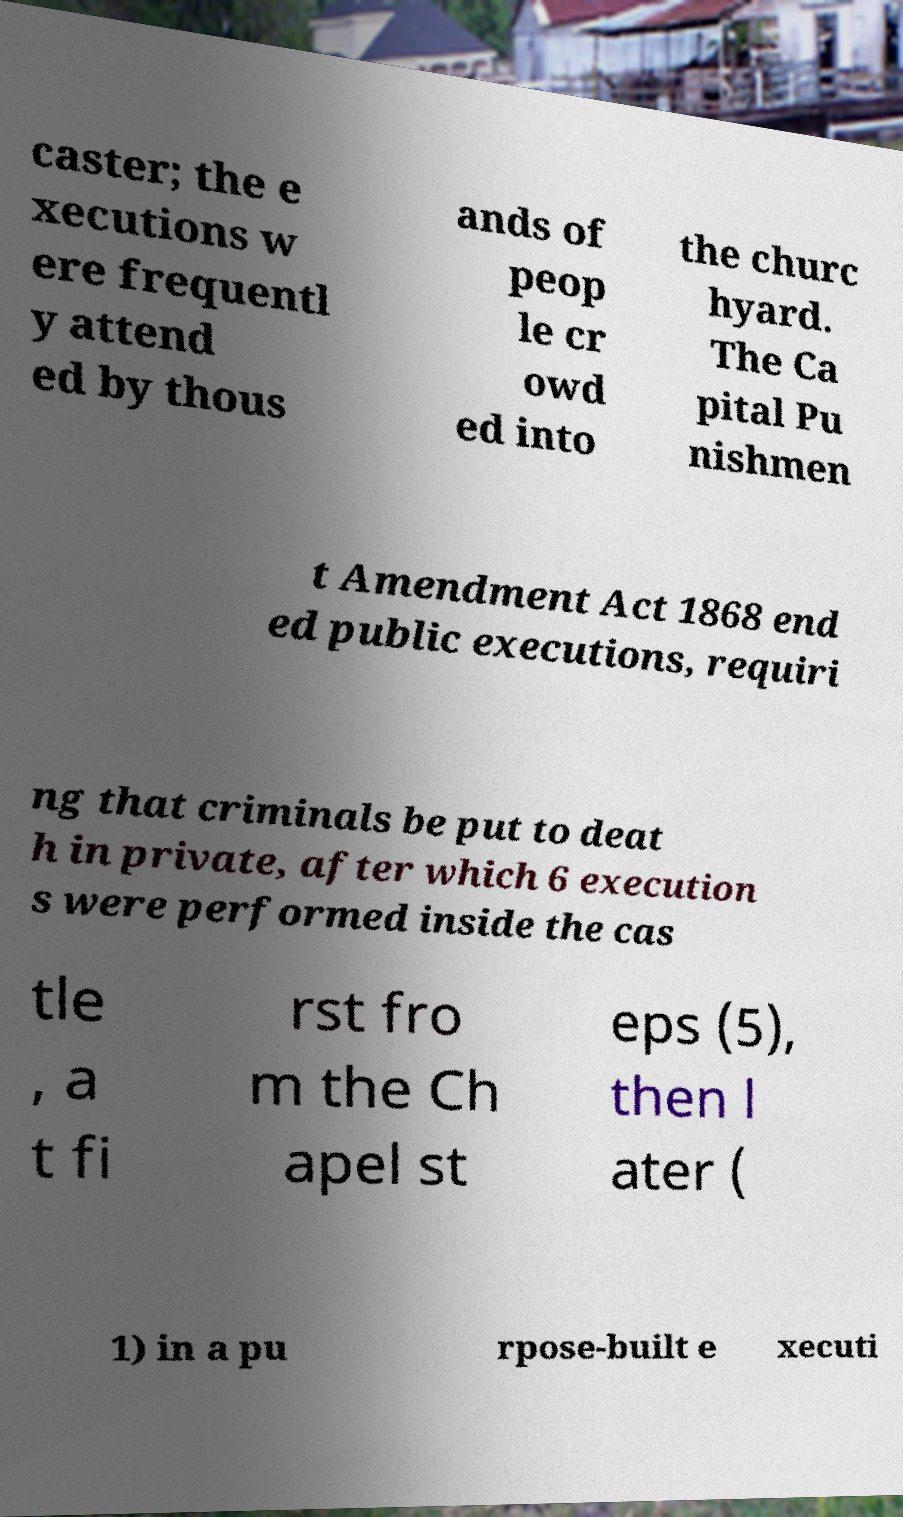Can you accurately transcribe the text from the provided image for me? caster; the e xecutions w ere frequentl y attend ed by thous ands of peop le cr owd ed into the churc hyard. The Ca pital Pu nishmen t Amendment Act 1868 end ed public executions, requiri ng that criminals be put to deat h in private, after which 6 execution s were performed inside the cas tle , a t fi rst fro m the Ch apel st eps (5), then l ater ( 1) in a pu rpose-built e xecuti 